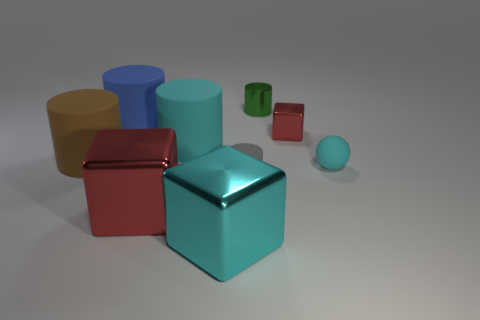Is there anything else that is the same shape as the tiny cyan thing?
Keep it short and to the point. No. What is the material of the big cylinder that is to the right of the red block that is on the left side of the tiny metallic object that is behind the tiny red thing?
Ensure brevity in your answer.  Rubber. There is a blue object that is the same size as the brown cylinder; what is its shape?
Make the answer very short. Cylinder. How many things are either tiny blue shiny objects or things that are behind the large red metallic cube?
Provide a short and direct response. 7. Is the material of the red thing that is in front of the small cyan ball the same as the cyan object on the right side of the tiny red block?
Offer a very short reply. No. There is a big metallic thing that is the same color as the tiny cube; what is its shape?
Offer a very short reply. Cube. What number of cyan objects are either matte balls or tiny metallic cylinders?
Your answer should be compact. 1. The brown thing has what size?
Make the answer very short. Large. Are there more small metallic blocks that are to the right of the big cyan cylinder than large red matte cylinders?
Provide a succinct answer. Yes. How many green shiny cylinders are in front of the large red shiny block?
Your answer should be compact. 0. 